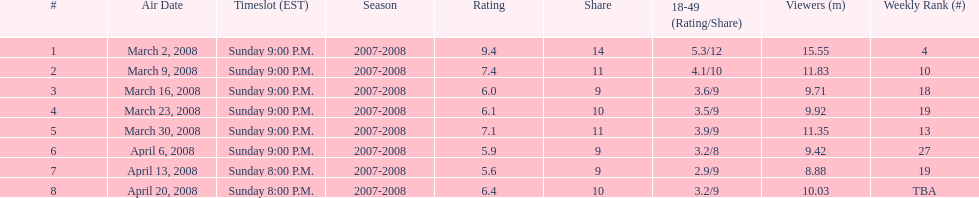What was the highest-rated episode? March 2, 2008. 